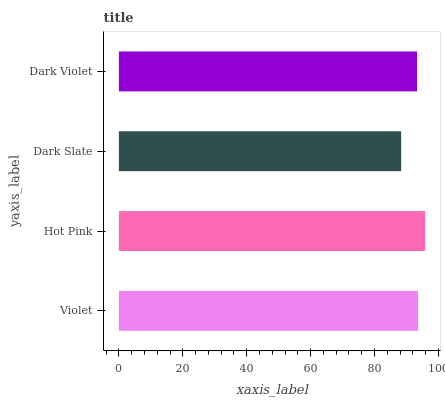Is Dark Slate the minimum?
Answer yes or no. Yes. Is Hot Pink the maximum?
Answer yes or no. Yes. Is Hot Pink the minimum?
Answer yes or no. No. Is Dark Slate the maximum?
Answer yes or no. No. Is Hot Pink greater than Dark Slate?
Answer yes or no. Yes. Is Dark Slate less than Hot Pink?
Answer yes or no. Yes. Is Dark Slate greater than Hot Pink?
Answer yes or no. No. Is Hot Pink less than Dark Slate?
Answer yes or no. No. Is Violet the high median?
Answer yes or no. Yes. Is Dark Violet the low median?
Answer yes or no. Yes. Is Dark Violet the high median?
Answer yes or no. No. Is Dark Slate the low median?
Answer yes or no. No. 